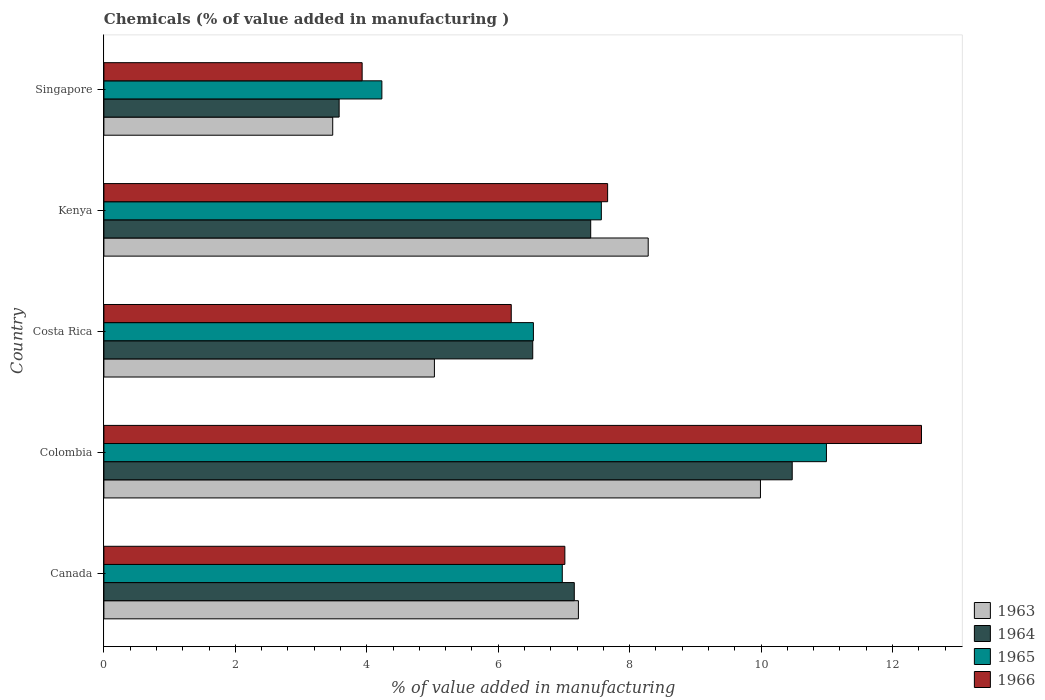How many groups of bars are there?
Provide a succinct answer. 5. Are the number of bars on each tick of the Y-axis equal?
Offer a very short reply. Yes. How many bars are there on the 2nd tick from the top?
Offer a terse response. 4. What is the label of the 1st group of bars from the top?
Ensure brevity in your answer.  Singapore. What is the value added in manufacturing chemicals in 1964 in Canada?
Your answer should be very brief. 7.16. Across all countries, what is the maximum value added in manufacturing chemicals in 1964?
Give a very brief answer. 10.47. Across all countries, what is the minimum value added in manufacturing chemicals in 1963?
Offer a terse response. 3.48. In which country was the value added in manufacturing chemicals in 1964 maximum?
Offer a very short reply. Colombia. In which country was the value added in manufacturing chemicals in 1963 minimum?
Your response must be concise. Singapore. What is the total value added in manufacturing chemicals in 1963 in the graph?
Offer a very short reply. 34.01. What is the difference between the value added in manufacturing chemicals in 1966 in Costa Rica and that in Kenya?
Make the answer very short. -1.47. What is the difference between the value added in manufacturing chemicals in 1963 in Colombia and the value added in manufacturing chemicals in 1965 in Canada?
Ensure brevity in your answer.  3.02. What is the average value added in manufacturing chemicals in 1963 per country?
Offer a terse response. 6.8. What is the difference between the value added in manufacturing chemicals in 1964 and value added in manufacturing chemicals in 1966 in Kenya?
Offer a very short reply. -0.26. What is the ratio of the value added in manufacturing chemicals in 1966 in Costa Rica to that in Kenya?
Provide a short and direct response. 0.81. What is the difference between the highest and the second highest value added in manufacturing chemicals in 1964?
Your answer should be very brief. 3.07. What is the difference between the highest and the lowest value added in manufacturing chemicals in 1966?
Offer a terse response. 8.51. Is it the case that in every country, the sum of the value added in manufacturing chemicals in 1964 and value added in manufacturing chemicals in 1966 is greater than the sum of value added in manufacturing chemicals in 1963 and value added in manufacturing chemicals in 1965?
Provide a short and direct response. No. What does the 2nd bar from the top in Costa Rica represents?
Give a very brief answer. 1965. How many bars are there?
Your response must be concise. 20. Are all the bars in the graph horizontal?
Give a very brief answer. Yes. How many countries are there in the graph?
Your answer should be compact. 5. Are the values on the major ticks of X-axis written in scientific E-notation?
Provide a succinct answer. No. Does the graph contain any zero values?
Keep it short and to the point. No. Does the graph contain grids?
Give a very brief answer. No. How many legend labels are there?
Provide a short and direct response. 4. What is the title of the graph?
Your answer should be compact. Chemicals (% of value added in manufacturing ). Does "1977" appear as one of the legend labels in the graph?
Provide a short and direct response. No. What is the label or title of the X-axis?
Give a very brief answer. % of value added in manufacturing. What is the label or title of the Y-axis?
Provide a short and direct response. Country. What is the % of value added in manufacturing of 1963 in Canada?
Keep it short and to the point. 7.22. What is the % of value added in manufacturing of 1964 in Canada?
Your response must be concise. 7.16. What is the % of value added in manufacturing of 1965 in Canada?
Provide a succinct answer. 6.98. What is the % of value added in manufacturing of 1966 in Canada?
Offer a very short reply. 7.01. What is the % of value added in manufacturing of 1963 in Colombia?
Your answer should be very brief. 9.99. What is the % of value added in manufacturing of 1964 in Colombia?
Keep it short and to the point. 10.47. What is the % of value added in manufacturing in 1965 in Colombia?
Your answer should be compact. 10.99. What is the % of value added in manufacturing in 1966 in Colombia?
Your answer should be very brief. 12.44. What is the % of value added in manufacturing in 1963 in Costa Rica?
Offer a very short reply. 5.03. What is the % of value added in manufacturing in 1964 in Costa Rica?
Make the answer very short. 6.53. What is the % of value added in manufacturing in 1965 in Costa Rica?
Provide a short and direct response. 6.54. What is the % of value added in manufacturing in 1966 in Costa Rica?
Provide a short and direct response. 6.2. What is the % of value added in manufacturing in 1963 in Kenya?
Provide a succinct answer. 8.28. What is the % of value added in manufacturing in 1964 in Kenya?
Ensure brevity in your answer.  7.41. What is the % of value added in manufacturing of 1965 in Kenya?
Offer a terse response. 7.57. What is the % of value added in manufacturing in 1966 in Kenya?
Keep it short and to the point. 7.67. What is the % of value added in manufacturing in 1963 in Singapore?
Your response must be concise. 3.48. What is the % of value added in manufacturing of 1964 in Singapore?
Offer a very short reply. 3.58. What is the % of value added in manufacturing in 1965 in Singapore?
Provide a short and direct response. 4.23. What is the % of value added in manufacturing of 1966 in Singapore?
Make the answer very short. 3.93. Across all countries, what is the maximum % of value added in manufacturing in 1963?
Provide a short and direct response. 9.99. Across all countries, what is the maximum % of value added in manufacturing in 1964?
Keep it short and to the point. 10.47. Across all countries, what is the maximum % of value added in manufacturing of 1965?
Ensure brevity in your answer.  10.99. Across all countries, what is the maximum % of value added in manufacturing of 1966?
Make the answer very short. 12.44. Across all countries, what is the minimum % of value added in manufacturing in 1963?
Give a very brief answer. 3.48. Across all countries, what is the minimum % of value added in manufacturing of 1964?
Keep it short and to the point. 3.58. Across all countries, what is the minimum % of value added in manufacturing of 1965?
Your answer should be very brief. 4.23. Across all countries, what is the minimum % of value added in manufacturing in 1966?
Provide a short and direct response. 3.93. What is the total % of value added in manufacturing in 1963 in the graph?
Provide a succinct answer. 34.01. What is the total % of value added in manufacturing in 1964 in the graph?
Your answer should be compact. 35.15. What is the total % of value added in manufacturing in 1965 in the graph?
Make the answer very short. 36.31. What is the total % of value added in manufacturing of 1966 in the graph?
Keep it short and to the point. 37.25. What is the difference between the % of value added in manufacturing of 1963 in Canada and that in Colombia?
Keep it short and to the point. -2.77. What is the difference between the % of value added in manufacturing in 1964 in Canada and that in Colombia?
Make the answer very short. -3.32. What is the difference between the % of value added in manufacturing in 1965 in Canada and that in Colombia?
Give a very brief answer. -4.02. What is the difference between the % of value added in manufacturing in 1966 in Canada and that in Colombia?
Make the answer very short. -5.43. What is the difference between the % of value added in manufacturing in 1963 in Canada and that in Costa Rica?
Make the answer very short. 2.19. What is the difference between the % of value added in manufacturing of 1964 in Canada and that in Costa Rica?
Keep it short and to the point. 0.63. What is the difference between the % of value added in manufacturing of 1965 in Canada and that in Costa Rica?
Keep it short and to the point. 0.44. What is the difference between the % of value added in manufacturing in 1966 in Canada and that in Costa Rica?
Your response must be concise. 0.82. What is the difference between the % of value added in manufacturing in 1963 in Canada and that in Kenya?
Offer a very short reply. -1.06. What is the difference between the % of value added in manufacturing of 1964 in Canada and that in Kenya?
Keep it short and to the point. -0.25. What is the difference between the % of value added in manufacturing in 1965 in Canada and that in Kenya?
Provide a short and direct response. -0.59. What is the difference between the % of value added in manufacturing in 1966 in Canada and that in Kenya?
Your response must be concise. -0.65. What is the difference between the % of value added in manufacturing of 1963 in Canada and that in Singapore?
Provide a short and direct response. 3.74. What is the difference between the % of value added in manufacturing of 1964 in Canada and that in Singapore?
Give a very brief answer. 3.58. What is the difference between the % of value added in manufacturing of 1965 in Canada and that in Singapore?
Provide a short and direct response. 2.75. What is the difference between the % of value added in manufacturing of 1966 in Canada and that in Singapore?
Give a very brief answer. 3.08. What is the difference between the % of value added in manufacturing of 1963 in Colombia and that in Costa Rica?
Ensure brevity in your answer.  4.96. What is the difference between the % of value added in manufacturing in 1964 in Colombia and that in Costa Rica?
Provide a short and direct response. 3.95. What is the difference between the % of value added in manufacturing of 1965 in Colombia and that in Costa Rica?
Provide a succinct answer. 4.46. What is the difference between the % of value added in manufacturing of 1966 in Colombia and that in Costa Rica?
Make the answer very short. 6.24. What is the difference between the % of value added in manufacturing in 1963 in Colombia and that in Kenya?
Offer a terse response. 1.71. What is the difference between the % of value added in manufacturing of 1964 in Colombia and that in Kenya?
Offer a terse response. 3.07. What is the difference between the % of value added in manufacturing of 1965 in Colombia and that in Kenya?
Offer a very short reply. 3.43. What is the difference between the % of value added in manufacturing of 1966 in Colombia and that in Kenya?
Keep it short and to the point. 4.78. What is the difference between the % of value added in manufacturing of 1963 in Colombia and that in Singapore?
Offer a very short reply. 6.51. What is the difference between the % of value added in manufacturing of 1964 in Colombia and that in Singapore?
Give a very brief answer. 6.89. What is the difference between the % of value added in manufacturing in 1965 in Colombia and that in Singapore?
Your response must be concise. 6.76. What is the difference between the % of value added in manufacturing in 1966 in Colombia and that in Singapore?
Give a very brief answer. 8.51. What is the difference between the % of value added in manufacturing in 1963 in Costa Rica and that in Kenya?
Your answer should be very brief. -3.25. What is the difference between the % of value added in manufacturing of 1964 in Costa Rica and that in Kenya?
Provide a short and direct response. -0.88. What is the difference between the % of value added in manufacturing in 1965 in Costa Rica and that in Kenya?
Offer a very short reply. -1.03. What is the difference between the % of value added in manufacturing of 1966 in Costa Rica and that in Kenya?
Give a very brief answer. -1.47. What is the difference between the % of value added in manufacturing in 1963 in Costa Rica and that in Singapore?
Provide a short and direct response. 1.55. What is the difference between the % of value added in manufacturing in 1964 in Costa Rica and that in Singapore?
Your response must be concise. 2.95. What is the difference between the % of value added in manufacturing in 1965 in Costa Rica and that in Singapore?
Your response must be concise. 2.31. What is the difference between the % of value added in manufacturing in 1966 in Costa Rica and that in Singapore?
Provide a succinct answer. 2.27. What is the difference between the % of value added in manufacturing of 1963 in Kenya and that in Singapore?
Offer a terse response. 4.8. What is the difference between the % of value added in manufacturing of 1964 in Kenya and that in Singapore?
Provide a succinct answer. 3.83. What is the difference between the % of value added in manufacturing in 1965 in Kenya and that in Singapore?
Offer a terse response. 3.34. What is the difference between the % of value added in manufacturing of 1966 in Kenya and that in Singapore?
Keep it short and to the point. 3.74. What is the difference between the % of value added in manufacturing of 1963 in Canada and the % of value added in manufacturing of 1964 in Colombia?
Your answer should be very brief. -3.25. What is the difference between the % of value added in manufacturing in 1963 in Canada and the % of value added in manufacturing in 1965 in Colombia?
Keep it short and to the point. -3.77. What is the difference between the % of value added in manufacturing in 1963 in Canada and the % of value added in manufacturing in 1966 in Colombia?
Provide a short and direct response. -5.22. What is the difference between the % of value added in manufacturing of 1964 in Canada and the % of value added in manufacturing of 1965 in Colombia?
Make the answer very short. -3.84. What is the difference between the % of value added in manufacturing of 1964 in Canada and the % of value added in manufacturing of 1966 in Colombia?
Provide a succinct answer. -5.28. What is the difference between the % of value added in manufacturing in 1965 in Canada and the % of value added in manufacturing in 1966 in Colombia?
Your answer should be compact. -5.47. What is the difference between the % of value added in manufacturing in 1963 in Canada and the % of value added in manufacturing in 1964 in Costa Rica?
Make the answer very short. 0.69. What is the difference between the % of value added in manufacturing of 1963 in Canada and the % of value added in manufacturing of 1965 in Costa Rica?
Your response must be concise. 0.68. What is the difference between the % of value added in manufacturing in 1963 in Canada and the % of value added in manufacturing in 1966 in Costa Rica?
Provide a short and direct response. 1.02. What is the difference between the % of value added in manufacturing in 1964 in Canada and the % of value added in manufacturing in 1965 in Costa Rica?
Offer a terse response. 0.62. What is the difference between the % of value added in manufacturing of 1964 in Canada and the % of value added in manufacturing of 1966 in Costa Rica?
Your answer should be compact. 0.96. What is the difference between the % of value added in manufacturing in 1965 in Canada and the % of value added in manufacturing in 1966 in Costa Rica?
Offer a terse response. 0.78. What is the difference between the % of value added in manufacturing in 1963 in Canada and the % of value added in manufacturing in 1964 in Kenya?
Offer a very short reply. -0.19. What is the difference between the % of value added in manufacturing of 1963 in Canada and the % of value added in manufacturing of 1965 in Kenya?
Ensure brevity in your answer.  -0.35. What is the difference between the % of value added in manufacturing of 1963 in Canada and the % of value added in manufacturing of 1966 in Kenya?
Offer a very short reply. -0.44. What is the difference between the % of value added in manufacturing of 1964 in Canada and the % of value added in manufacturing of 1965 in Kenya?
Ensure brevity in your answer.  -0.41. What is the difference between the % of value added in manufacturing in 1964 in Canada and the % of value added in manufacturing in 1966 in Kenya?
Your answer should be very brief. -0.51. What is the difference between the % of value added in manufacturing of 1965 in Canada and the % of value added in manufacturing of 1966 in Kenya?
Your response must be concise. -0.69. What is the difference between the % of value added in manufacturing of 1963 in Canada and the % of value added in manufacturing of 1964 in Singapore?
Your answer should be compact. 3.64. What is the difference between the % of value added in manufacturing of 1963 in Canada and the % of value added in manufacturing of 1965 in Singapore?
Your response must be concise. 2.99. What is the difference between the % of value added in manufacturing of 1963 in Canada and the % of value added in manufacturing of 1966 in Singapore?
Your answer should be very brief. 3.29. What is the difference between the % of value added in manufacturing of 1964 in Canada and the % of value added in manufacturing of 1965 in Singapore?
Provide a succinct answer. 2.93. What is the difference between the % of value added in manufacturing in 1964 in Canada and the % of value added in manufacturing in 1966 in Singapore?
Provide a succinct answer. 3.23. What is the difference between the % of value added in manufacturing of 1965 in Canada and the % of value added in manufacturing of 1966 in Singapore?
Your answer should be very brief. 3.05. What is the difference between the % of value added in manufacturing in 1963 in Colombia and the % of value added in manufacturing in 1964 in Costa Rica?
Make the answer very short. 3.47. What is the difference between the % of value added in manufacturing of 1963 in Colombia and the % of value added in manufacturing of 1965 in Costa Rica?
Your answer should be very brief. 3.46. What is the difference between the % of value added in manufacturing of 1963 in Colombia and the % of value added in manufacturing of 1966 in Costa Rica?
Provide a short and direct response. 3.79. What is the difference between the % of value added in manufacturing of 1964 in Colombia and the % of value added in manufacturing of 1965 in Costa Rica?
Ensure brevity in your answer.  3.94. What is the difference between the % of value added in manufacturing of 1964 in Colombia and the % of value added in manufacturing of 1966 in Costa Rica?
Make the answer very short. 4.28. What is the difference between the % of value added in manufacturing of 1965 in Colombia and the % of value added in manufacturing of 1966 in Costa Rica?
Give a very brief answer. 4.8. What is the difference between the % of value added in manufacturing of 1963 in Colombia and the % of value added in manufacturing of 1964 in Kenya?
Offer a very short reply. 2.58. What is the difference between the % of value added in manufacturing in 1963 in Colombia and the % of value added in manufacturing in 1965 in Kenya?
Provide a succinct answer. 2.42. What is the difference between the % of value added in manufacturing of 1963 in Colombia and the % of value added in manufacturing of 1966 in Kenya?
Provide a short and direct response. 2.33. What is the difference between the % of value added in manufacturing of 1964 in Colombia and the % of value added in manufacturing of 1965 in Kenya?
Your answer should be compact. 2.9. What is the difference between the % of value added in manufacturing in 1964 in Colombia and the % of value added in manufacturing in 1966 in Kenya?
Your answer should be very brief. 2.81. What is the difference between the % of value added in manufacturing of 1965 in Colombia and the % of value added in manufacturing of 1966 in Kenya?
Your answer should be very brief. 3.33. What is the difference between the % of value added in manufacturing of 1963 in Colombia and the % of value added in manufacturing of 1964 in Singapore?
Your response must be concise. 6.41. What is the difference between the % of value added in manufacturing of 1963 in Colombia and the % of value added in manufacturing of 1965 in Singapore?
Make the answer very short. 5.76. What is the difference between the % of value added in manufacturing in 1963 in Colombia and the % of value added in manufacturing in 1966 in Singapore?
Provide a short and direct response. 6.06. What is the difference between the % of value added in manufacturing in 1964 in Colombia and the % of value added in manufacturing in 1965 in Singapore?
Offer a very short reply. 6.24. What is the difference between the % of value added in manufacturing in 1964 in Colombia and the % of value added in manufacturing in 1966 in Singapore?
Keep it short and to the point. 6.54. What is the difference between the % of value added in manufacturing in 1965 in Colombia and the % of value added in manufacturing in 1966 in Singapore?
Offer a very short reply. 7.07. What is the difference between the % of value added in manufacturing in 1963 in Costa Rica and the % of value added in manufacturing in 1964 in Kenya?
Give a very brief answer. -2.38. What is the difference between the % of value added in manufacturing in 1963 in Costa Rica and the % of value added in manufacturing in 1965 in Kenya?
Your response must be concise. -2.54. What is the difference between the % of value added in manufacturing of 1963 in Costa Rica and the % of value added in manufacturing of 1966 in Kenya?
Ensure brevity in your answer.  -2.64. What is the difference between the % of value added in manufacturing in 1964 in Costa Rica and the % of value added in manufacturing in 1965 in Kenya?
Ensure brevity in your answer.  -1.04. What is the difference between the % of value added in manufacturing of 1964 in Costa Rica and the % of value added in manufacturing of 1966 in Kenya?
Provide a short and direct response. -1.14. What is the difference between the % of value added in manufacturing of 1965 in Costa Rica and the % of value added in manufacturing of 1966 in Kenya?
Your answer should be compact. -1.13. What is the difference between the % of value added in manufacturing of 1963 in Costa Rica and the % of value added in manufacturing of 1964 in Singapore?
Provide a short and direct response. 1.45. What is the difference between the % of value added in manufacturing in 1963 in Costa Rica and the % of value added in manufacturing in 1965 in Singapore?
Provide a succinct answer. 0.8. What is the difference between the % of value added in manufacturing of 1963 in Costa Rica and the % of value added in manufacturing of 1966 in Singapore?
Offer a very short reply. 1.1. What is the difference between the % of value added in manufacturing in 1964 in Costa Rica and the % of value added in manufacturing in 1965 in Singapore?
Your answer should be very brief. 2.3. What is the difference between the % of value added in manufacturing in 1964 in Costa Rica and the % of value added in manufacturing in 1966 in Singapore?
Offer a terse response. 2.6. What is the difference between the % of value added in manufacturing in 1965 in Costa Rica and the % of value added in manufacturing in 1966 in Singapore?
Offer a very short reply. 2.61. What is the difference between the % of value added in manufacturing in 1963 in Kenya and the % of value added in manufacturing in 1964 in Singapore?
Provide a succinct answer. 4.7. What is the difference between the % of value added in manufacturing of 1963 in Kenya and the % of value added in manufacturing of 1965 in Singapore?
Your response must be concise. 4.05. What is the difference between the % of value added in manufacturing in 1963 in Kenya and the % of value added in manufacturing in 1966 in Singapore?
Give a very brief answer. 4.35. What is the difference between the % of value added in manufacturing of 1964 in Kenya and the % of value added in manufacturing of 1965 in Singapore?
Your response must be concise. 3.18. What is the difference between the % of value added in manufacturing in 1964 in Kenya and the % of value added in manufacturing in 1966 in Singapore?
Keep it short and to the point. 3.48. What is the difference between the % of value added in manufacturing in 1965 in Kenya and the % of value added in manufacturing in 1966 in Singapore?
Keep it short and to the point. 3.64. What is the average % of value added in manufacturing of 1963 per country?
Offer a terse response. 6.8. What is the average % of value added in manufacturing in 1964 per country?
Offer a terse response. 7.03. What is the average % of value added in manufacturing of 1965 per country?
Make the answer very short. 7.26. What is the average % of value added in manufacturing in 1966 per country?
Offer a very short reply. 7.45. What is the difference between the % of value added in manufacturing of 1963 and % of value added in manufacturing of 1964 in Canada?
Your answer should be very brief. 0.06. What is the difference between the % of value added in manufacturing in 1963 and % of value added in manufacturing in 1965 in Canada?
Keep it short and to the point. 0.25. What is the difference between the % of value added in manufacturing in 1963 and % of value added in manufacturing in 1966 in Canada?
Make the answer very short. 0.21. What is the difference between the % of value added in manufacturing in 1964 and % of value added in manufacturing in 1965 in Canada?
Your response must be concise. 0.18. What is the difference between the % of value added in manufacturing in 1964 and % of value added in manufacturing in 1966 in Canada?
Offer a terse response. 0.14. What is the difference between the % of value added in manufacturing of 1965 and % of value added in manufacturing of 1966 in Canada?
Your answer should be very brief. -0.04. What is the difference between the % of value added in manufacturing of 1963 and % of value added in manufacturing of 1964 in Colombia?
Ensure brevity in your answer.  -0.48. What is the difference between the % of value added in manufacturing of 1963 and % of value added in manufacturing of 1965 in Colombia?
Give a very brief answer. -1. What is the difference between the % of value added in manufacturing of 1963 and % of value added in manufacturing of 1966 in Colombia?
Offer a very short reply. -2.45. What is the difference between the % of value added in manufacturing of 1964 and % of value added in manufacturing of 1965 in Colombia?
Offer a terse response. -0.52. What is the difference between the % of value added in manufacturing in 1964 and % of value added in manufacturing in 1966 in Colombia?
Make the answer very short. -1.97. What is the difference between the % of value added in manufacturing of 1965 and % of value added in manufacturing of 1966 in Colombia?
Offer a terse response. -1.45. What is the difference between the % of value added in manufacturing of 1963 and % of value added in manufacturing of 1964 in Costa Rica?
Provide a short and direct response. -1.5. What is the difference between the % of value added in manufacturing in 1963 and % of value added in manufacturing in 1965 in Costa Rica?
Give a very brief answer. -1.51. What is the difference between the % of value added in manufacturing of 1963 and % of value added in manufacturing of 1966 in Costa Rica?
Provide a succinct answer. -1.17. What is the difference between the % of value added in manufacturing of 1964 and % of value added in manufacturing of 1965 in Costa Rica?
Your answer should be compact. -0.01. What is the difference between the % of value added in manufacturing of 1964 and % of value added in manufacturing of 1966 in Costa Rica?
Ensure brevity in your answer.  0.33. What is the difference between the % of value added in manufacturing of 1965 and % of value added in manufacturing of 1966 in Costa Rica?
Make the answer very short. 0.34. What is the difference between the % of value added in manufacturing of 1963 and % of value added in manufacturing of 1964 in Kenya?
Provide a succinct answer. 0.87. What is the difference between the % of value added in manufacturing of 1963 and % of value added in manufacturing of 1965 in Kenya?
Keep it short and to the point. 0.71. What is the difference between the % of value added in manufacturing of 1963 and % of value added in manufacturing of 1966 in Kenya?
Provide a succinct answer. 0.62. What is the difference between the % of value added in manufacturing of 1964 and % of value added in manufacturing of 1965 in Kenya?
Your answer should be compact. -0.16. What is the difference between the % of value added in manufacturing of 1964 and % of value added in manufacturing of 1966 in Kenya?
Ensure brevity in your answer.  -0.26. What is the difference between the % of value added in manufacturing in 1965 and % of value added in manufacturing in 1966 in Kenya?
Offer a very short reply. -0.1. What is the difference between the % of value added in manufacturing of 1963 and % of value added in manufacturing of 1964 in Singapore?
Your answer should be very brief. -0.1. What is the difference between the % of value added in manufacturing in 1963 and % of value added in manufacturing in 1965 in Singapore?
Offer a terse response. -0.75. What is the difference between the % of value added in manufacturing of 1963 and % of value added in manufacturing of 1966 in Singapore?
Your answer should be very brief. -0.45. What is the difference between the % of value added in manufacturing in 1964 and % of value added in manufacturing in 1965 in Singapore?
Your answer should be very brief. -0.65. What is the difference between the % of value added in manufacturing in 1964 and % of value added in manufacturing in 1966 in Singapore?
Provide a succinct answer. -0.35. What is the difference between the % of value added in manufacturing in 1965 and % of value added in manufacturing in 1966 in Singapore?
Your answer should be very brief. 0.3. What is the ratio of the % of value added in manufacturing of 1963 in Canada to that in Colombia?
Provide a short and direct response. 0.72. What is the ratio of the % of value added in manufacturing of 1964 in Canada to that in Colombia?
Provide a short and direct response. 0.68. What is the ratio of the % of value added in manufacturing of 1965 in Canada to that in Colombia?
Your answer should be compact. 0.63. What is the ratio of the % of value added in manufacturing in 1966 in Canada to that in Colombia?
Your answer should be very brief. 0.56. What is the ratio of the % of value added in manufacturing of 1963 in Canada to that in Costa Rica?
Make the answer very short. 1.44. What is the ratio of the % of value added in manufacturing in 1964 in Canada to that in Costa Rica?
Your response must be concise. 1.1. What is the ratio of the % of value added in manufacturing of 1965 in Canada to that in Costa Rica?
Keep it short and to the point. 1.07. What is the ratio of the % of value added in manufacturing in 1966 in Canada to that in Costa Rica?
Give a very brief answer. 1.13. What is the ratio of the % of value added in manufacturing of 1963 in Canada to that in Kenya?
Provide a short and direct response. 0.87. What is the ratio of the % of value added in manufacturing of 1964 in Canada to that in Kenya?
Provide a short and direct response. 0.97. What is the ratio of the % of value added in manufacturing of 1965 in Canada to that in Kenya?
Make the answer very short. 0.92. What is the ratio of the % of value added in manufacturing of 1966 in Canada to that in Kenya?
Your response must be concise. 0.92. What is the ratio of the % of value added in manufacturing in 1963 in Canada to that in Singapore?
Ensure brevity in your answer.  2.07. What is the ratio of the % of value added in manufacturing in 1964 in Canada to that in Singapore?
Keep it short and to the point. 2. What is the ratio of the % of value added in manufacturing of 1965 in Canada to that in Singapore?
Your response must be concise. 1.65. What is the ratio of the % of value added in manufacturing of 1966 in Canada to that in Singapore?
Provide a succinct answer. 1.78. What is the ratio of the % of value added in manufacturing in 1963 in Colombia to that in Costa Rica?
Your response must be concise. 1.99. What is the ratio of the % of value added in manufacturing in 1964 in Colombia to that in Costa Rica?
Offer a very short reply. 1.61. What is the ratio of the % of value added in manufacturing in 1965 in Colombia to that in Costa Rica?
Provide a short and direct response. 1.68. What is the ratio of the % of value added in manufacturing of 1966 in Colombia to that in Costa Rica?
Provide a short and direct response. 2.01. What is the ratio of the % of value added in manufacturing of 1963 in Colombia to that in Kenya?
Keep it short and to the point. 1.21. What is the ratio of the % of value added in manufacturing of 1964 in Colombia to that in Kenya?
Your answer should be compact. 1.41. What is the ratio of the % of value added in manufacturing of 1965 in Colombia to that in Kenya?
Your answer should be compact. 1.45. What is the ratio of the % of value added in manufacturing in 1966 in Colombia to that in Kenya?
Your answer should be very brief. 1.62. What is the ratio of the % of value added in manufacturing of 1963 in Colombia to that in Singapore?
Provide a short and direct response. 2.87. What is the ratio of the % of value added in manufacturing of 1964 in Colombia to that in Singapore?
Your response must be concise. 2.93. What is the ratio of the % of value added in manufacturing in 1965 in Colombia to that in Singapore?
Your answer should be compact. 2.6. What is the ratio of the % of value added in manufacturing of 1966 in Colombia to that in Singapore?
Offer a terse response. 3.17. What is the ratio of the % of value added in manufacturing in 1963 in Costa Rica to that in Kenya?
Make the answer very short. 0.61. What is the ratio of the % of value added in manufacturing in 1964 in Costa Rica to that in Kenya?
Give a very brief answer. 0.88. What is the ratio of the % of value added in manufacturing of 1965 in Costa Rica to that in Kenya?
Your answer should be compact. 0.86. What is the ratio of the % of value added in manufacturing in 1966 in Costa Rica to that in Kenya?
Your response must be concise. 0.81. What is the ratio of the % of value added in manufacturing of 1963 in Costa Rica to that in Singapore?
Your response must be concise. 1.44. What is the ratio of the % of value added in manufacturing of 1964 in Costa Rica to that in Singapore?
Offer a very short reply. 1.82. What is the ratio of the % of value added in manufacturing in 1965 in Costa Rica to that in Singapore?
Your answer should be compact. 1.55. What is the ratio of the % of value added in manufacturing of 1966 in Costa Rica to that in Singapore?
Your answer should be very brief. 1.58. What is the ratio of the % of value added in manufacturing of 1963 in Kenya to that in Singapore?
Your answer should be compact. 2.38. What is the ratio of the % of value added in manufacturing in 1964 in Kenya to that in Singapore?
Offer a very short reply. 2.07. What is the ratio of the % of value added in manufacturing of 1965 in Kenya to that in Singapore?
Your answer should be compact. 1.79. What is the ratio of the % of value added in manufacturing in 1966 in Kenya to that in Singapore?
Your answer should be very brief. 1.95. What is the difference between the highest and the second highest % of value added in manufacturing in 1963?
Keep it short and to the point. 1.71. What is the difference between the highest and the second highest % of value added in manufacturing of 1964?
Give a very brief answer. 3.07. What is the difference between the highest and the second highest % of value added in manufacturing of 1965?
Ensure brevity in your answer.  3.43. What is the difference between the highest and the second highest % of value added in manufacturing in 1966?
Provide a succinct answer. 4.78. What is the difference between the highest and the lowest % of value added in manufacturing in 1963?
Offer a very short reply. 6.51. What is the difference between the highest and the lowest % of value added in manufacturing of 1964?
Your answer should be compact. 6.89. What is the difference between the highest and the lowest % of value added in manufacturing in 1965?
Your answer should be compact. 6.76. What is the difference between the highest and the lowest % of value added in manufacturing of 1966?
Offer a very short reply. 8.51. 